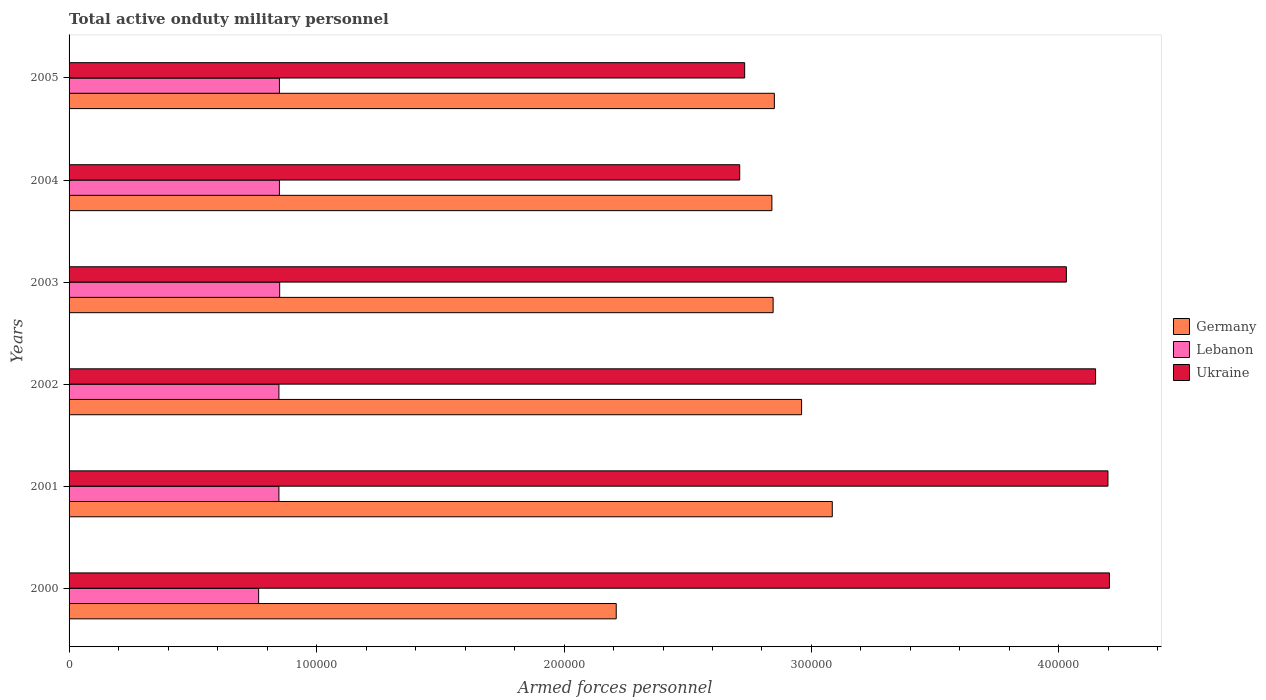How many different coloured bars are there?
Provide a succinct answer. 3. Are the number of bars on each tick of the Y-axis equal?
Provide a short and direct response. Yes. What is the label of the 3rd group of bars from the top?
Make the answer very short. 2003. What is the number of armed forces personnel in Germany in 2001?
Your response must be concise. 3.08e+05. Across all years, what is the maximum number of armed forces personnel in Germany?
Your answer should be very brief. 3.08e+05. Across all years, what is the minimum number of armed forces personnel in Lebanon?
Make the answer very short. 7.66e+04. In which year was the number of armed forces personnel in Germany minimum?
Provide a short and direct response. 2000. What is the total number of armed forces personnel in Lebanon in the graph?
Your answer should be very brief. 5.01e+05. What is the difference between the number of armed forces personnel in Germany in 2000 and that in 2005?
Provide a succinct answer. -6.39e+04. What is the difference between the number of armed forces personnel in Ukraine in 2005 and the number of armed forces personnel in Lebanon in 2002?
Provide a succinct answer. 1.88e+05. What is the average number of armed forces personnel in Lebanon per year?
Offer a terse response. 8.36e+04. In the year 2000, what is the difference between the number of armed forces personnel in Ukraine and number of armed forces personnel in Germany?
Ensure brevity in your answer.  1.99e+05. What is the ratio of the number of armed forces personnel in Lebanon in 2000 to that in 2002?
Keep it short and to the point. 0.9. Is the difference between the number of armed forces personnel in Ukraine in 2000 and 2005 greater than the difference between the number of armed forces personnel in Germany in 2000 and 2005?
Your response must be concise. Yes. What is the difference between the highest and the second highest number of armed forces personnel in Lebanon?
Your answer should be very brief. 100. What is the difference between the highest and the lowest number of armed forces personnel in Ukraine?
Make the answer very short. 1.49e+05. In how many years, is the number of armed forces personnel in Lebanon greater than the average number of armed forces personnel in Lebanon taken over all years?
Make the answer very short. 5. What does the 2nd bar from the top in 2002 represents?
Your response must be concise. Lebanon. What does the 3rd bar from the bottom in 2005 represents?
Your answer should be compact. Ukraine. Is it the case that in every year, the sum of the number of armed forces personnel in Ukraine and number of armed forces personnel in Germany is greater than the number of armed forces personnel in Lebanon?
Offer a terse response. Yes. How many bars are there?
Provide a succinct answer. 18. What is the difference between two consecutive major ticks on the X-axis?
Your answer should be very brief. 1.00e+05. Are the values on the major ticks of X-axis written in scientific E-notation?
Your answer should be very brief. No. Where does the legend appear in the graph?
Your response must be concise. Center right. How many legend labels are there?
Provide a succinct answer. 3. How are the legend labels stacked?
Provide a short and direct response. Vertical. What is the title of the graph?
Offer a terse response. Total active onduty military personnel. Does "Tanzania" appear as one of the legend labels in the graph?
Provide a short and direct response. No. What is the label or title of the X-axis?
Your response must be concise. Armed forces personnel. What is the label or title of the Y-axis?
Offer a very short reply. Years. What is the Armed forces personnel in Germany in 2000?
Your answer should be very brief. 2.21e+05. What is the Armed forces personnel in Lebanon in 2000?
Ensure brevity in your answer.  7.66e+04. What is the Armed forces personnel of Ukraine in 2000?
Give a very brief answer. 4.20e+05. What is the Armed forces personnel in Germany in 2001?
Offer a very short reply. 3.08e+05. What is the Armed forces personnel of Lebanon in 2001?
Make the answer very short. 8.48e+04. What is the Armed forces personnel in Ukraine in 2001?
Provide a short and direct response. 4.20e+05. What is the Armed forces personnel in Germany in 2002?
Make the answer very short. 2.96e+05. What is the Armed forces personnel of Lebanon in 2002?
Your response must be concise. 8.48e+04. What is the Armed forces personnel of Ukraine in 2002?
Your answer should be compact. 4.15e+05. What is the Armed forces personnel in Germany in 2003?
Keep it short and to the point. 2.84e+05. What is the Armed forces personnel of Lebanon in 2003?
Your answer should be compact. 8.51e+04. What is the Armed forces personnel of Ukraine in 2003?
Offer a very short reply. 4.03e+05. What is the Armed forces personnel of Germany in 2004?
Ensure brevity in your answer.  2.84e+05. What is the Armed forces personnel in Lebanon in 2004?
Offer a very short reply. 8.50e+04. What is the Armed forces personnel in Ukraine in 2004?
Provide a succinct answer. 2.71e+05. What is the Armed forces personnel in Germany in 2005?
Your response must be concise. 2.85e+05. What is the Armed forces personnel of Lebanon in 2005?
Offer a terse response. 8.50e+04. What is the Armed forces personnel in Ukraine in 2005?
Your answer should be compact. 2.73e+05. Across all years, what is the maximum Armed forces personnel of Germany?
Offer a terse response. 3.08e+05. Across all years, what is the maximum Armed forces personnel in Lebanon?
Provide a succinct answer. 8.51e+04. Across all years, what is the maximum Armed forces personnel in Ukraine?
Your answer should be very brief. 4.20e+05. Across all years, what is the minimum Armed forces personnel of Germany?
Offer a terse response. 2.21e+05. Across all years, what is the minimum Armed forces personnel in Lebanon?
Ensure brevity in your answer.  7.66e+04. Across all years, what is the minimum Armed forces personnel of Ukraine?
Keep it short and to the point. 2.71e+05. What is the total Armed forces personnel in Germany in the graph?
Provide a succinct answer. 1.68e+06. What is the total Armed forces personnel of Lebanon in the graph?
Provide a short and direct response. 5.01e+05. What is the total Armed forces personnel of Ukraine in the graph?
Offer a very short reply. 2.20e+06. What is the difference between the Armed forces personnel in Germany in 2000 and that in 2001?
Give a very brief answer. -8.73e+04. What is the difference between the Armed forces personnel in Lebanon in 2000 and that in 2001?
Your answer should be very brief. -8200. What is the difference between the Armed forces personnel of Ukraine in 2000 and that in 2001?
Provide a short and direct response. 600. What is the difference between the Armed forces personnel of Germany in 2000 and that in 2002?
Offer a terse response. -7.49e+04. What is the difference between the Armed forces personnel of Lebanon in 2000 and that in 2002?
Offer a terse response. -8200. What is the difference between the Armed forces personnel in Ukraine in 2000 and that in 2002?
Your answer should be very brief. 5600. What is the difference between the Armed forces personnel of Germany in 2000 and that in 2003?
Make the answer very short. -6.34e+04. What is the difference between the Armed forces personnel in Lebanon in 2000 and that in 2003?
Provide a short and direct response. -8500. What is the difference between the Armed forces personnel of Ukraine in 2000 and that in 2003?
Make the answer very short. 1.74e+04. What is the difference between the Armed forces personnel in Germany in 2000 and that in 2004?
Provide a succinct answer. -6.29e+04. What is the difference between the Armed forces personnel in Lebanon in 2000 and that in 2004?
Provide a succinct answer. -8400. What is the difference between the Armed forces personnel in Ukraine in 2000 and that in 2004?
Keep it short and to the point. 1.49e+05. What is the difference between the Armed forces personnel of Germany in 2000 and that in 2005?
Provide a short and direct response. -6.39e+04. What is the difference between the Armed forces personnel in Lebanon in 2000 and that in 2005?
Your answer should be compact. -8400. What is the difference between the Armed forces personnel of Ukraine in 2000 and that in 2005?
Your response must be concise. 1.47e+05. What is the difference between the Armed forces personnel of Germany in 2001 and that in 2002?
Your answer should be compact. 1.24e+04. What is the difference between the Armed forces personnel in Ukraine in 2001 and that in 2002?
Your answer should be compact. 5000. What is the difference between the Armed forces personnel in Germany in 2001 and that in 2003?
Your response must be concise. 2.39e+04. What is the difference between the Armed forces personnel of Lebanon in 2001 and that in 2003?
Offer a very short reply. -300. What is the difference between the Armed forces personnel in Ukraine in 2001 and that in 2003?
Ensure brevity in your answer.  1.68e+04. What is the difference between the Armed forces personnel of Germany in 2001 and that in 2004?
Provide a succinct answer. 2.44e+04. What is the difference between the Armed forces personnel of Lebanon in 2001 and that in 2004?
Offer a terse response. -200. What is the difference between the Armed forces personnel of Ukraine in 2001 and that in 2004?
Give a very brief answer. 1.49e+05. What is the difference between the Armed forces personnel in Germany in 2001 and that in 2005?
Offer a terse response. 2.34e+04. What is the difference between the Armed forces personnel of Lebanon in 2001 and that in 2005?
Offer a terse response. -200. What is the difference between the Armed forces personnel in Ukraine in 2001 and that in 2005?
Make the answer very short. 1.47e+05. What is the difference between the Armed forces personnel of Germany in 2002 and that in 2003?
Give a very brief answer. 1.15e+04. What is the difference between the Armed forces personnel in Lebanon in 2002 and that in 2003?
Your response must be concise. -300. What is the difference between the Armed forces personnel in Ukraine in 2002 and that in 2003?
Ensure brevity in your answer.  1.18e+04. What is the difference between the Armed forces personnel of Germany in 2002 and that in 2004?
Provide a succinct answer. 1.20e+04. What is the difference between the Armed forces personnel in Lebanon in 2002 and that in 2004?
Your answer should be compact. -200. What is the difference between the Armed forces personnel in Ukraine in 2002 and that in 2004?
Your response must be concise. 1.44e+05. What is the difference between the Armed forces personnel in Germany in 2002 and that in 2005?
Provide a short and direct response. 1.10e+04. What is the difference between the Armed forces personnel in Lebanon in 2002 and that in 2005?
Keep it short and to the point. -200. What is the difference between the Armed forces personnel of Ukraine in 2002 and that in 2005?
Ensure brevity in your answer.  1.42e+05. What is the difference between the Armed forces personnel of Ukraine in 2003 and that in 2004?
Your answer should be very brief. 1.32e+05. What is the difference between the Armed forces personnel in Germany in 2003 and that in 2005?
Make the answer very short. -500. What is the difference between the Armed forces personnel in Lebanon in 2003 and that in 2005?
Provide a succinct answer. 100. What is the difference between the Armed forces personnel of Germany in 2004 and that in 2005?
Your response must be concise. -1000. What is the difference between the Armed forces personnel of Ukraine in 2004 and that in 2005?
Keep it short and to the point. -2000. What is the difference between the Armed forces personnel in Germany in 2000 and the Armed forces personnel in Lebanon in 2001?
Your response must be concise. 1.36e+05. What is the difference between the Armed forces personnel of Germany in 2000 and the Armed forces personnel of Ukraine in 2001?
Your response must be concise. -1.99e+05. What is the difference between the Armed forces personnel of Lebanon in 2000 and the Armed forces personnel of Ukraine in 2001?
Provide a short and direct response. -3.43e+05. What is the difference between the Armed forces personnel of Germany in 2000 and the Armed forces personnel of Lebanon in 2002?
Your answer should be very brief. 1.36e+05. What is the difference between the Armed forces personnel in Germany in 2000 and the Armed forces personnel in Ukraine in 2002?
Keep it short and to the point. -1.94e+05. What is the difference between the Armed forces personnel of Lebanon in 2000 and the Armed forces personnel of Ukraine in 2002?
Offer a terse response. -3.38e+05. What is the difference between the Armed forces personnel of Germany in 2000 and the Armed forces personnel of Lebanon in 2003?
Keep it short and to the point. 1.36e+05. What is the difference between the Armed forces personnel in Germany in 2000 and the Armed forces personnel in Ukraine in 2003?
Give a very brief answer. -1.82e+05. What is the difference between the Armed forces personnel of Lebanon in 2000 and the Armed forces personnel of Ukraine in 2003?
Keep it short and to the point. -3.26e+05. What is the difference between the Armed forces personnel of Germany in 2000 and the Armed forces personnel of Lebanon in 2004?
Offer a terse response. 1.36e+05. What is the difference between the Armed forces personnel of Germany in 2000 and the Armed forces personnel of Ukraine in 2004?
Offer a very short reply. -4.99e+04. What is the difference between the Armed forces personnel in Lebanon in 2000 and the Armed forces personnel in Ukraine in 2004?
Your response must be concise. -1.94e+05. What is the difference between the Armed forces personnel in Germany in 2000 and the Armed forces personnel in Lebanon in 2005?
Make the answer very short. 1.36e+05. What is the difference between the Armed forces personnel in Germany in 2000 and the Armed forces personnel in Ukraine in 2005?
Offer a terse response. -5.19e+04. What is the difference between the Armed forces personnel of Lebanon in 2000 and the Armed forces personnel of Ukraine in 2005?
Your response must be concise. -1.96e+05. What is the difference between the Armed forces personnel of Germany in 2001 and the Armed forces personnel of Lebanon in 2002?
Keep it short and to the point. 2.24e+05. What is the difference between the Armed forces personnel of Germany in 2001 and the Armed forces personnel of Ukraine in 2002?
Give a very brief answer. -1.06e+05. What is the difference between the Armed forces personnel in Lebanon in 2001 and the Armed forces personnel in Ukraine in 2002?
Ensure brevity in your answer.  -3.30e+05. What is the difference between the Armed forces personnel in Germany in 2001 and the Armed forces personnel in Lebanon in 2003?
Keep it short and to the point. 2.23e+05. What is the difference between the Armed forces personnel of Germany in 2001 and the Armed forces personnel of Ukraine in 2003?
Give a very brief answer. -9.46e+04. What is the difference between the Armed forces personnel of Lebanon in 2001 and the Armed forces personnel of Ukraine in 2003?
Your answer should be compact. -3.18e+05. What is the difference between the Armed forces personnel of Germany in 2001 and the Armed forces personnel of Lebanon in 2004?
Make the answer very short. 2.23e+05. What is the difference between the Armed forces personnel in Germany in 2001 and the Armed forces personnel in Ukraine in 2004?
Ensure brevity in your answer.  3.74e+04. What is the difference between the Armed forces personnel of Lebanon in 2001 and the Armed forces personnel of Ukraine in 2004?
Your response must be concise. -1.86e+05. What is the difference between the Armed forces personnel in Germany in 2001 and the Armed forces personnel in Lebanon in 2005?
Give a very brief answer. 2.23e+05. What is the difference between the Armed forces personnel in Germany in 2001 and the Armed forces personnel in Ukraine in 2005?
Provide a short and direct response. 3.54e+04. What is the difference between the Armed forces personnel in Lebanon in 2001 and the Armed forces personnel in Ukraine in 2005?
Provide a succinct answer. -1.88e+05. What is the difference between the Armed forces personnel in Germany in 2002 and the Armed forces personnel in Lebanon in 2003?
Your response must be concise. 2.11e+05. What is the difference between the Armed forces personnel of Germany in 2002 and the Armed forces personnel of Ukraine in 2003?
Give a very brief answer. -1.07e+05. What is the difference between the Armed forces personnel in Lebanon in 2002 and the Armed forces personnel in Ukraine in 2003?
Ensure brevity in your answer.  -3.18e+05. What is the difference between the Armed forces personnel in Germany in 2002 and the Armed forces personnel in Lebanon in 2004?
Provide a short and direct response. 2.11e+05. What is the difference between the Armed forces personnel of Germany in 2002 and the Armed forces personnel of Ukraine in 2004?
Your answer should be compact. 2.50e+04. What is the difference between the Armed forces personnel in Lebanon in 2002 and the Armed forces personnel in Ukraine in 2004?
Provide a succinct answer. -1.86e+05. What is the difference between the Armed forces personnel in Germany in 2002 and the Armed forces personnel in Lebanon in 2005?
Keep it short and to the point. 2.11e+05. What is the difference between the Armed forces personnel of Germany in 2002 and the Armed forces personnel of Ukraine in 2005?
Offer a terse response. 2.30e+04. What is the difference between the Armed forces personnel of Lebanon in 2002 and the Armed forces personnel of Ukraine in 2005?
Offer a terse response. -1.88e+05. What is the difference between the Armed forces personnel of Germany in 2003 and the Armed forces personnel of Lebanon in 2004?
Keep it short and to the point. 2.00e+05. What is the difference between the Armed forces personnel in Germany in 2003 and the Armed forces personnel in Ukraine in 2004?
Offer a terse response. 1.35e+04. What is the difference between the Armed forces personnel in Lebanon in 2003 and the Armed forces personnel in Ukraine in 2004?
Keep it short and to the point. -1.86e+05. What is the difference between the Armed forces personnel in Germany in 2003 and the Armed forces personnel in Lebanon in 2005?
Your answer should be compact. 2.00e+05. What is the difference between the Armed forces personnel in Germany in 2003 and the Armed forces personnel in Ukraine in 2005?
Your answer should be very brief. 1.15e+04. What is the difference between the Armed forces personnel in Lebanon in 2003 and the Armed forces personnel in Ukraine in 2005?
Make the answer very short. -1.88e+05. What is the difference between the Armed forces personnel of Germany in 2004 and the Armed forces personnel of Lebanon in 2005?
Ensure brevity in your answer.  1.99e+05. What is the difference between the Armed forces personnel of Germany in 2004 and the Armed forces personnel of Ukraine in 2005?
Give a very brief answer. 1.10e+04. What is the difference between the Armed forces personnel in Lebanon in 2004 and the Armed forces personnel in Ukraine in 2005?
Keep it short and to the point. -1.88e+05. What is the average Armed forces personnel of Germany per year?
Keep it short and to the point. 2.80e+05. What is the average Armed forces personnel in Lebanon per year?
Keep it short and to the point. 8.36e+04. What is the average Armed forces personnel of Ukraine per year?
Ensure brevity in your answer.  3.67e+05. In the year 2000, what is the difference between the Armed forces personnel of Germany and Armed forces personnel of Lebanon?
Offer a very short reply. 1.44e+05. In the year 2000, what is the difference between the Armed forces personnel in Germany and Armed forces personnel in Ukraine?
Ensure brevity in your answer.  -1.99e+05. In the year 2000, what is the difference between the Armed forces personnel in Lebanon and Armed forces personnel in Ukraine?
Give a very brief answer. -3.44e+05. In the year 2001, what is the difference between the Armed forces personnel in Germany and Armed forces personnel in Lebanon?
Offer a very short reply. 2.24e+05. In the year 2001, what is the difference between the Armed forces personnel in Germany and Armed forces personnel in Ukraine?
Ensure brevity in your answer.  -1.11e+05. In the year 2001, what is the difference between the Armed forces personnel in Lebanon and Armed forces personnel in Ukraine?
Give a very brief answer. -3.35e+05. In the year 2002, what is the difference between the Armed forces personnel in Germany and Armed forces personnel in Lebanon?
Offer a terse response. 2.11e+05. In the year 2002, what is the difference between the Armed forces personnel of Germany and Armed forces personnel of Ukraine?
Your answer should be compact. -1.19e+05. In the year 2002, what is the difference between the Armed forces personnel in Lebanon and Armed forces personnel in Ukraine?
Your answer should be compact. -3.30e+05. In the year 2003, what is the difference between the Armed forces personnel in Germany and Armed forces personnel in Lebanon?
Give a very brief answer. 1.99e+05. In the year 2003, what is the difference between the Armed forces personnel in Germany and Armed forces personnel in Ukraine?
Offer a terse response. -1.18e+05. In the year 2003, what is the difference between the Armed forces personnel of Lebanon and Armed forces personnel of Ukraine?
Provide a short and direct response. -3.18e+05. In the year 2004, what is the difference between the Armed forces personnel of Germany and Armed forces personnel of Lebanon?
Make the answer very short. 1.99e+05. In the year 2004, what is the difference between the Armed forces personnel in Germany and Armed forces personnel in Ukraine?
Your answer should be compact. 1.30e+04. In the year 2004, what is the difference between the Armed forces personnel of Lebanon and Armed forces personnel of Ukraine?
Give a very brief answer. -1.86e+05. In the year 2005, what is the difference between the Armed forces personnel of Germany and Armed forces personnel of Lebanon?
Offer a very short reply. 2.00e+05. In the year 2005, what is the difference between the Armed forces personnel in Germany and Armed forces personnel in Ukraine?
Provide a succinct answer. 1.20e+04. In the year 2005, what is the difference between the Armed forces personnel of Lebanon and Armed forces personnel of Ukraine?
Your answer should be very brief. -1.88e+05. What is the ratio of the Armed forces personnel of Germany in 2000 to that in 2001?
Keep it short and to the point. 0.72. What is the ratio of the Armed forces personnel in Lebanon in 2000 to that in 2001?
Make the answer very short. 0.9. What is the ratio of the Armed forces personnel of Germany in 2000 to that in 2002?
Your answer should be very brief. 0.75. What is the ratio of the Armed forces personnel in Lebanon in 2000 to that in 2002?
Make the answer very short. 0.9. What is the ratio of the Armed forces personnel in Ukraine in 2000 to that in 2002?
Your answer should be compact. 1.01. What is the ratio of the Armed forces personnel of Germany in 2000 to that in 2003?
Give a very brief answer. 0.78. What is the ratio of the Armed forces personnel in Lebanon in 2000 to that in 2003?
Your answer should be compact. 0.9. What is the ratio of the Armed forces personnel in Ukraine in 2000 to that in 2003?
Keep it short and to the point. 1.04. What is the ratio of the Armed forces personnel in Germany in 2000 to that in 2004?
Give a very brief answer. 0.78. What is the ratio of the Armed forces personnel in Lebanon in 2000 to that in 2004?
Ensure brevity in your answer.  0.9. What is the ratio of the Armed forces personnel in Ukraine in 2000 to that in 2004?
Your answer should be very brief. 1.55. What is the ratio of the Armed forces personnel of Germany in 2000 to that in 2005?
Your answer should be very brief. 0.78. What is the ratio of the Armed forces personnel of Lebanon in 2000 to that in 2005?
Keep it short and to the point. 0.9. What is the ratio of the Armed forces personnel of Ukraine in 2000 to that in 2005?
Your answer should be very brief. 1.54. What is the ratio of the Armed forces personnel in Germany in 2001 to that in 2002?
Your answer should be very brief. 1.04. What is the ratio of the Armed forces personnel of Ukraine in 2001 to that in 2002?
Ensure brevity in your answer.  1.01. What is the ratio of the Armed forces personnel in Germany in 2001 to that in 2003?
Your response must be concise. 1.08. What is the ratio of the Armed forces personnel of Lebanon in 2001 to that in 2003?
Keep it short and to the point. 1. What is the ratio of the Armed forces personnel of Ukraine in 2001 to that in 2003?
Your response must be concise. 1.04. What is the ratio of the Armed forces personnel in Germany in 2001 to that in 2004?
Your answer should be very brief. 1.09. What is the ratio of the Armed forces personnel in Ukraine in 2001 to that in 2004?
Provide a succinct answer. 1.55. What is the ratio of the Armed forces personnel of Germany in 2001 to that in 2005?
Provide a short and direct response. 1.08. What is the ratio of the Armed forces personnel of Ukraine in 2001 to that in 2005?
Keep it short and to the point. 1.54. What is the ratio of the Armed forces personnel of Germany in 2002 to that in 2003?
Keep it short and to the point. 1.04. What is the ratio of the Armed forces personnel in Lebanon in 2002 to that in 2003?
Your answer should be compact. 1. What is the ratio of the Armed forces personnel of Ukraine in 2002 to that in 2003?
Provide a succinct answer. 1.03. What is the ratio of the Armed forces personnel in Germany in 2002 to that in 2004?
Provide a succinct answer. 1.04. What is the ratio of the Armed forces personnel of Ukraine in 2002 to that in 2004?
Your answer should be very brief. 1.53. What is the ratio of the Armed forces personnel in Germany in 2002 to that in 2005?
Offer a terse response. 1.04. What is the ratio of the Armed forces personnel in Lebanon in 2002 to that in 2005?
Ensure brevity in your answer.  1. What is the ratio of the Armed forces personnel of Ukraine in 2002 to that in 2005?
Provide a short and direct response. 1.52. What is the ratio of the Armed forces personnel of Lebanon in 2003 to that in 2004?
Keep it short and to the point. 1. What is the ratio of the Armed forces personnel of Ukraine in 2003 to that in 2004?
Your response must be concise. 1.49. What is the ratio of the Armed forces personnel in Lebanon in 2003 to that in 2005?
Give a very brief answer. 1. What is the ratio of the Armed forces personnel in Ukraine in 2003 to that in 2005?
Make the answer very short. 1.48. What is the ratio of the Armed forces personnel of Lebanon in 2004 to that in 2005?
Provide a succinct answer. 1. What is the difference between the highest and the second highest Armed forces personnel in Germany?
Offer a very short reply. 1.24e+04. What is the difference between the highest and the second highest Armed forces personnel in Ukraine?
Offer a terse response. 600. What is the difference between the highest and the lowest Armed forces personnel of Germany?
Your answer should be very brief. 8.73e+04. What is the difference between the highest and the lowest Armed forces personnel in Lebanon?
Give a very brief answer. 8500. What is the difference between the highest and the lowest Armed forces personnel of Ukraine?
Your response must be concise. 1.49e+05. 